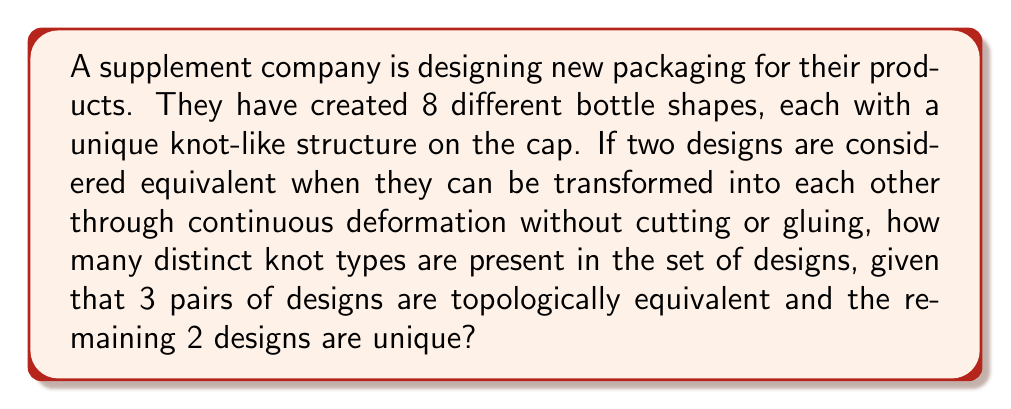Can you answer this question? To solve this problem, we need to apply concepts from Knot Theory to the packaging designs. Let's break it down step-by-step:

1. Total number of designs:
   We start with 8 different bottle designs.

2. Equivalent designs:
   There are 3 pairs of designs that are topologically equivalent. This means:
   $3 \times 2 = 6$ designs are part of equivalent pairs.

3. Unique designs:
   The remaining 2 designs are unique.

4. Calculating distinct knot types:
   - Each pair of equivalent designs counts as 1 distinct knot type.
   - Each unique design counts as 1 distinct knot type.

   So, we have:
   $$\text{Distinct knot types} = \text{Number of equivalent pairs} + \text{Number of unique designs}$$
   $$\text{Distinct knot types} = 3 + 2 = 5$$

Therefore, there are 5 distinct knot types in the set of supplement packaging designs.
Answer: 5 